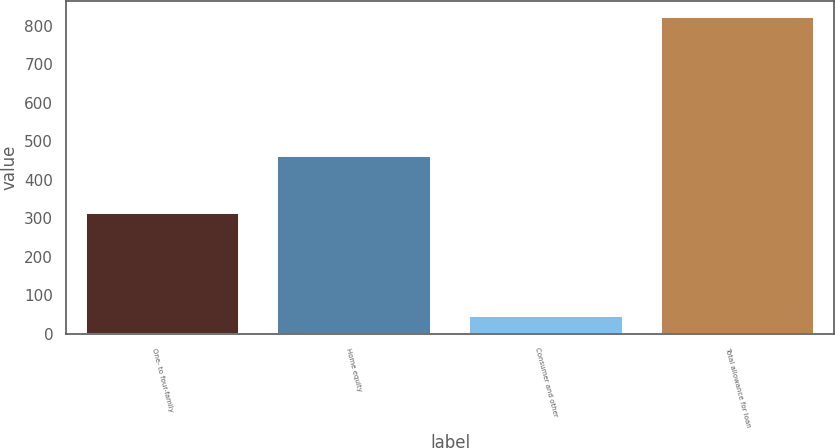Convert chart to OTSL. <chart><loc_0><loc_0><loc_500><loc_500><bar_chart><fcel>One- to four-family<fcel>Home equity<fcel>Consumer and other<fcel>Total allowance for loan<nl><fcel>314<fcel>463<fcel>46<fcel>823<nl></chart> 